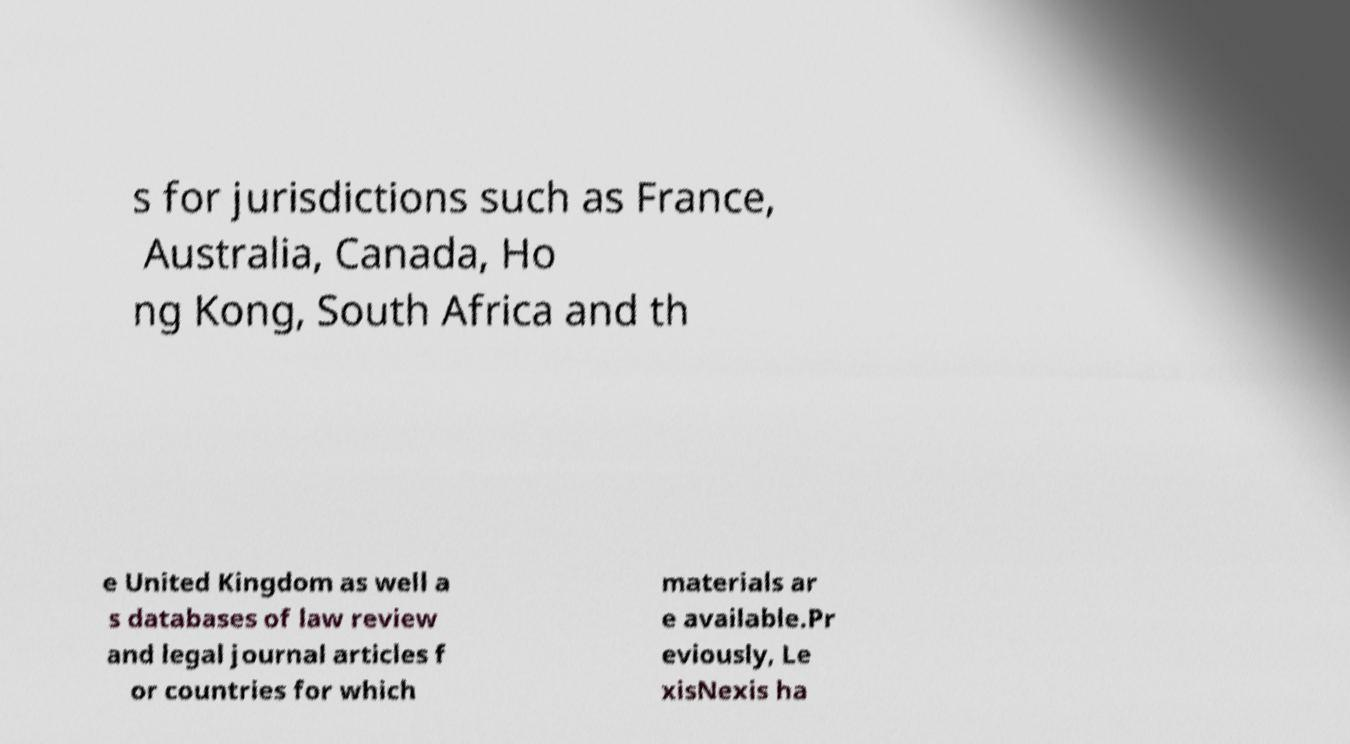Can you accurately transcribe the text from the provided image for me? s for jurisdictions such as France, Australia, Canada, Ho ng Kong, South Africa and th e United Kingdom as well a s databases of law review and legal journal articles f or countries for which materials ar e available.Pr eviously, Le xisNexis ha 